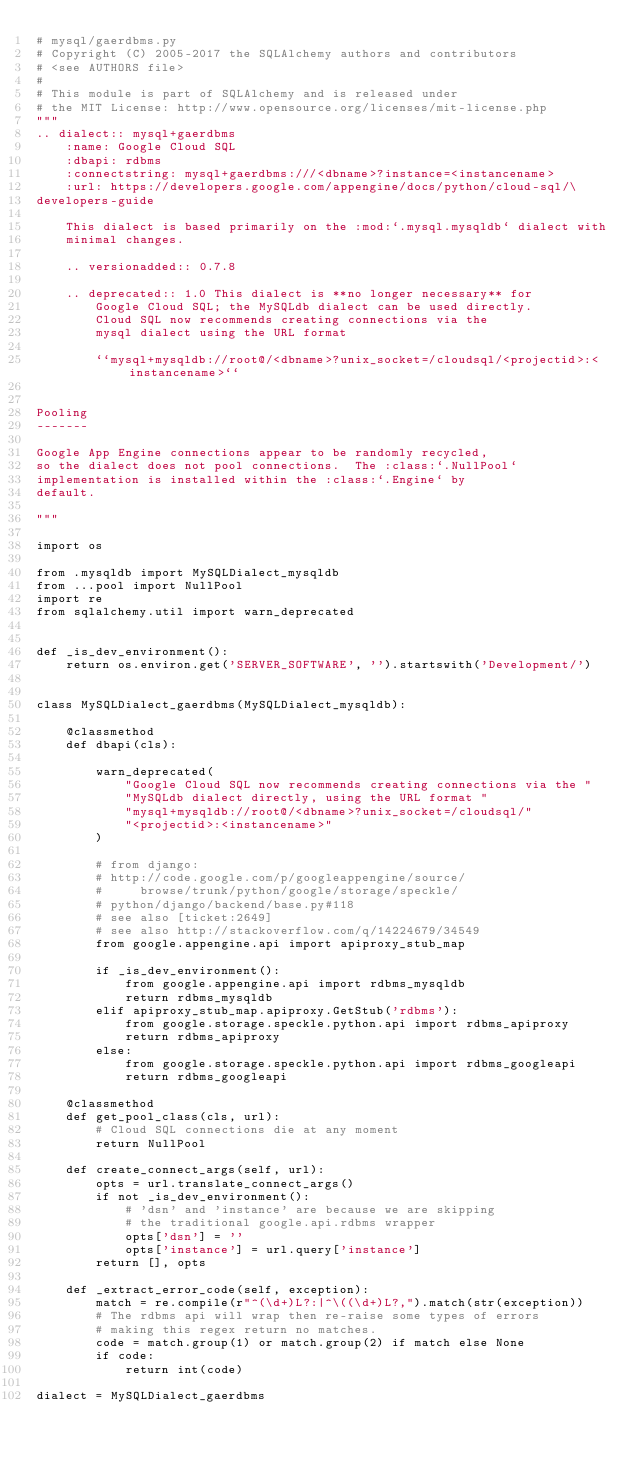Convert code to text. <code><loc_0><loc_0><loc_500><loc_500><_Python_># mysql/gaerdbms.py
# Copyright (C) 2005-2017 the SQLAlchemy authors and contributors
# <see AUTHORS file>
#
# This module is part of SQLAlchemy and is released under
# the MIT License: http://www.opensource.org/licenses/mit-license.php
"""
.. dialect:: mysql+gaerdbms
    :name: Google Cloud SQL
    :dbapi: rdbms
    :connectstring: mysql+gaerdbms:///<dbname>?instance=<instancename>
    :url: https://developers.google.com/appengine/docs/python/cloud-sql/\
developers-guide

    This dialect is based primarily on the :mod:`.mysql.mysqldb` dialect with
    minimal changes.

    .. versionadded:: 0.7.8

    .. deprecated:: 1.0 This dialect is **no longer necessary** for
        Google Cloud SQL; the MySQLdb dialect can be used directly.
        Cloud SQL now recommends creating connections via the
        mysql dialect using the URL format

        ``mysql+mysqldb://root@/<dbname>?unix_socket=/cloudsql/<projectid>:<instancename>``


Pooling
-------

Google App Engine connections appear to be randomly recycled,
so the dialect does not pool connections.  The :class:`.NullPool`
implementation is installed within the :class:`.Engine` by
default.

"""

import os

from .mysqldb import MySQLDialect_mysqldb
from ...pool import NullPool
import re
from sqlalchemy.util import warn_deprecated


def _is_dev_environment():
    return os.environ.get('SERVER_SOFTWARE', '').startswith('Development/')


class MySQLDialect_gaerdbms(MySQLDialect_mysqldb):

    @classmethod
    def dbapi(cls):

        warn_deprecated(
            "Google Cloud SQL now recommends creating connections via the "
            "MySQLdb dialect directly, using the URL format "
            "mysql+mysqldb://root@/<dbname>?unix_socket=/cloudsql/"
            "<projectid>:<instancename>"
        )

        # from django:
        # http://code.google.com/p/googleappengine/source/
        #     browse/trunk/python/google/storage/speckle/
        # python/django/backend/base.py#118
        # see also [ticket:2649]
        # see also http://stackoverflow.com/q/14224679/34549
        from google.appengine.api import apiproxy_stub_map

        if _is_dev_environment():
            from google.appengine.api import rdbms_mysqldb
            return rdbms_mysqldb
        elif apiproxy_stub_map.apiproxy.GetStub('rdbms'):
            from google.storage.speckle.python.api import rdbms_apiproxy
            return rdbms_apiproxy
        else:
            from google.storage.speckle.python.api import rdbms_googleapi
            return rdbms_googleapi

    @classmethod
    def get_pool_class(cls, url):
        # Cloud SQL connections die at any moment
        return NullPool

    def create_connect_args(self, url):
        opts = url.translate_connect_args()
        if not _is_dev_environment():
            # 'dsn' and 'instance' are because we are skipping
            # the traditional google.api.rdbms wrapper
            opts['dsn'] = ''
            opts['instance'] = url.query['instance']
        return [], opts

    def _extract_error_code(self, exception):
        match = re.compile(r"^(\d+)L?:|^\((\d+)L?,").match(str(exception))
        # The rdbms api will wrap then re-raise some types of errors
        # making this regex return no matches.
        code = match.group(1) or match.group(2) if match else None
        if code:
            return int(code)

dialect = MySQLDialect_gaerdbms
</code> 